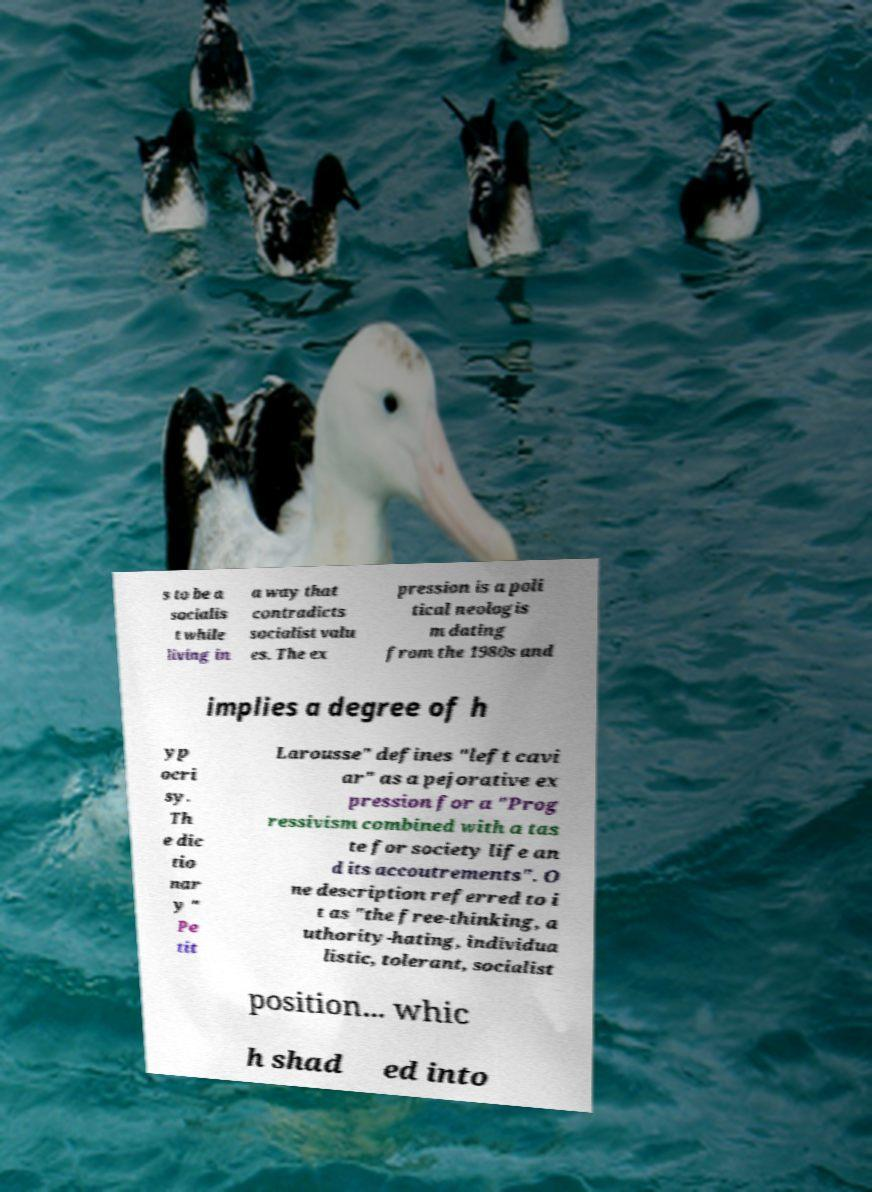Please identify and transcribe the text found in this image. s to be a socialis t while living in a way that contradicts socialist valu es. The ex pression is a poli tical neologis m dating from the 1980s and implies a degree of h yp ocri sy. Th e dic tio nar y " Pe tit Larousse" defines "left cavi ar" as a pejorative ex pression for a "Prog ressivism combined with a tas te for society life an d its accoutrements". O ne description referred to i t as "the free-thinking, a uthority-hating, individua listic, tolerant, socialist position... whic h shad ed into 